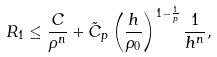Convert formula to latex. <formula><loc_0><loc_0><loc_500><loc_500>R _ { 1 } \leq \frac { C } { \rho ^ { n } } + \tilde { C } _ { p } \left ( \frac { h } { \rho _ { 0 } } \right ) ^ { 1 - \frac { 1 } { p } } \frac { 1 } { h ^ { n } } ,</formula> 